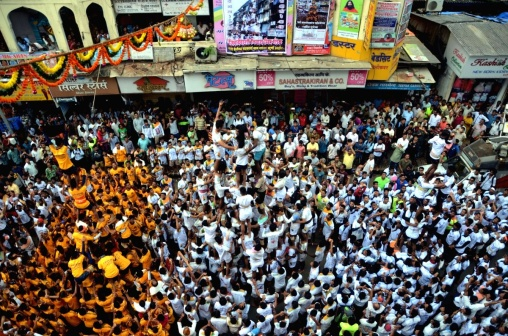What do you see happening in this image? The image captures an exuberant street celebration, possibly a festival, judging by the sea of people predominantly dressed in white and orange attire. They appear to be congregated around a central point of interest, which suggests a performance or a significant event taking place there. The street is overflowing with activity and the presence of shops and buildings provides an urban context. Overhead, decorative elements can be seen, implying a special occasion. Although no text can be perceived to provide context, the joyful nature of the gathering and the organized assembly of participants point to a planned, cultural or religious celebration. 